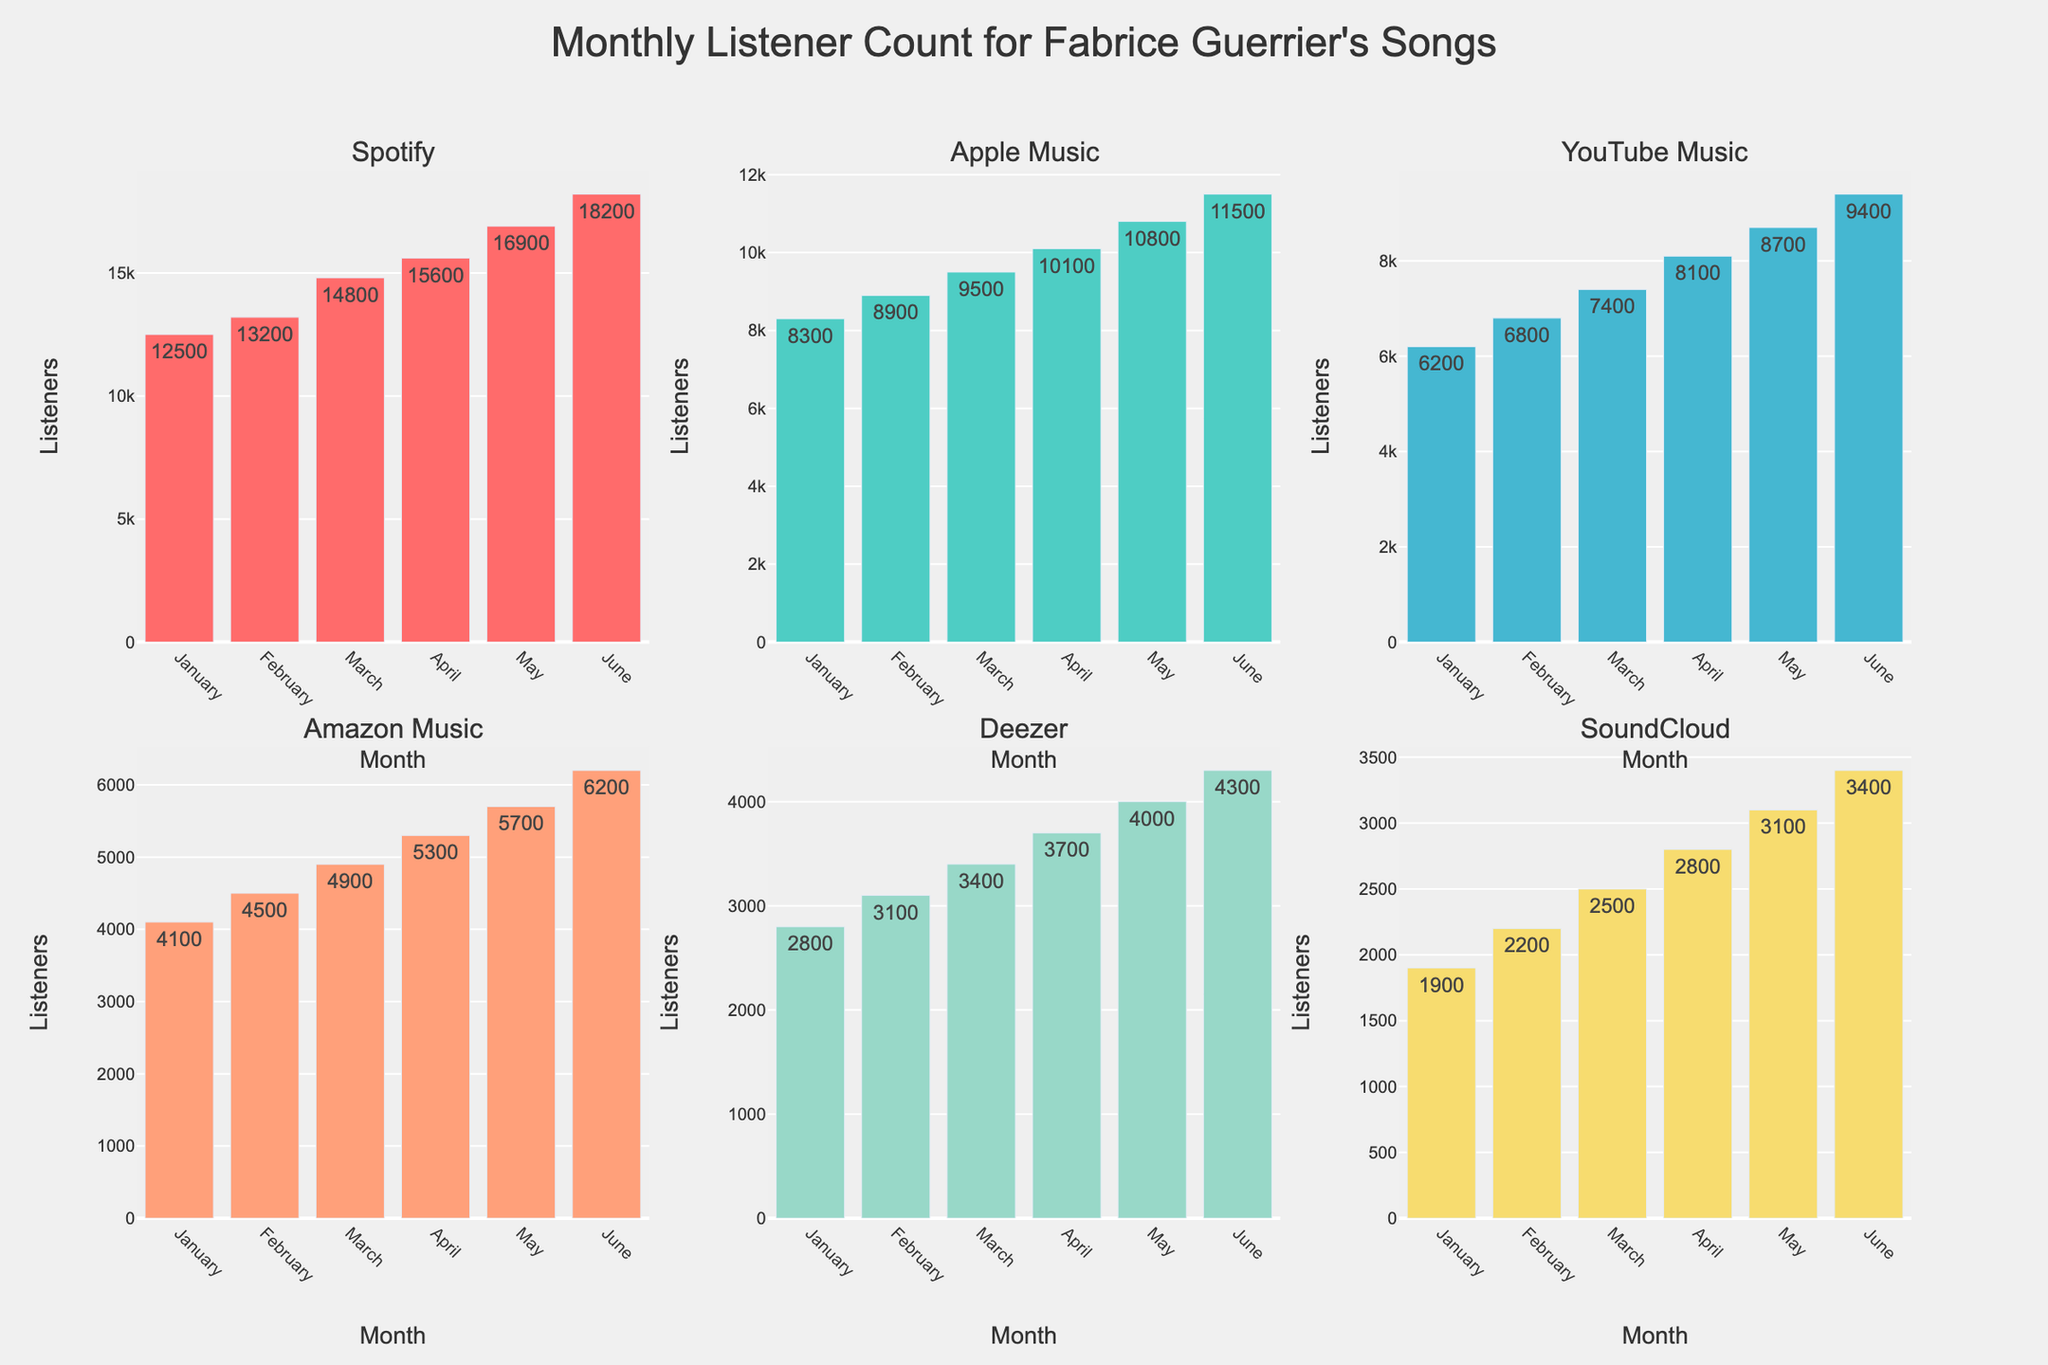Which platform has the highest number of monthly listeners in June? Look at the bar charts for each platform and compare the heights of the bars for June. Spotify has the highest bar.
Answer: Spotify Which platform has the lowest listeners in January? Compare the heights of the bars for each platform in January. The lowest bar is for SoundCloud.
Answer: SoundCloud What is the average monthly listener count for Deezer from January to June? Deezer’s monthly counts are: 2800, 3100, 3400, 3700, 4000, 4300. Sum these up (2800 + 3100 + 3400 + 3700 + 4000 + 4300 = 21300) and divide by 6 to get the average. 21300 / 6 = 3550
Answer: 3550 By how much did Apple Music's listener count increase from January to June? Subtract Apple Music’s January count from its June count (11500 - 8300). The increase is 11500 - 8300 = 3200
Answer: 3200 Which platform showed the largest growth in listener count from January to June? Calculate the difference between January and June counts for each platform and compare them. Spotify increased by (18200 - 12500 = 5700), which is the largest growth.
Answer: Spotify How many platforms have more than 10,000 listeners in May? Check the bar heights for each platform in May and count those exceeding 10,000 listeners. Spotify and Apple Music exceed 10,000 listeners, totaling 2 platforms.
Answer: 2 Is there a month where all platforms show an increase in listeners compared to the previous month? Verify that the bar heights for all platforms increase month-over-month for at least one month. From May to June, each platform shows an increase.
Answer: Yes, from May to June Which month does Amazon Music exceed 5,000 listeners for the first time? Compare the heights of Amazon Music’s bars month by month until it surpasses 5000. It exceeds 5,000 listeners in March.
Answer: March What's the total listener count across all platforms in April? Sum up the listener counts for all platforms in April: 15600 (Spotify) + 10100 (Apple Music) + 8100 (YouTube Music) + 5300 (Amazon Music) + 3700 (Deezer) + 2800 (SoundCloud). Total is 45600.
Answer: 45600 